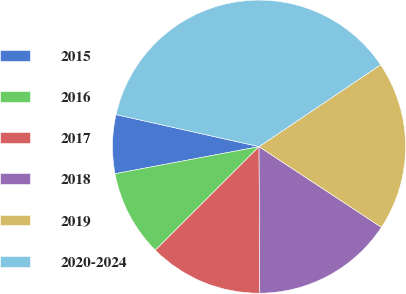Convert chart to OTSL. <chart><loc_0><loc_0><loc_500><loc_500><pie_chart><fcel>2015<fcel>2016<fcel>2017<fcel>2018<fcel>2019<fcel>2020-2024<nl><fcel>6.47%<fcel>9.53%<fcel>12.59%<fcel>15.65%<fcel>18.71%<fcel>37.06%<nl></chart> 